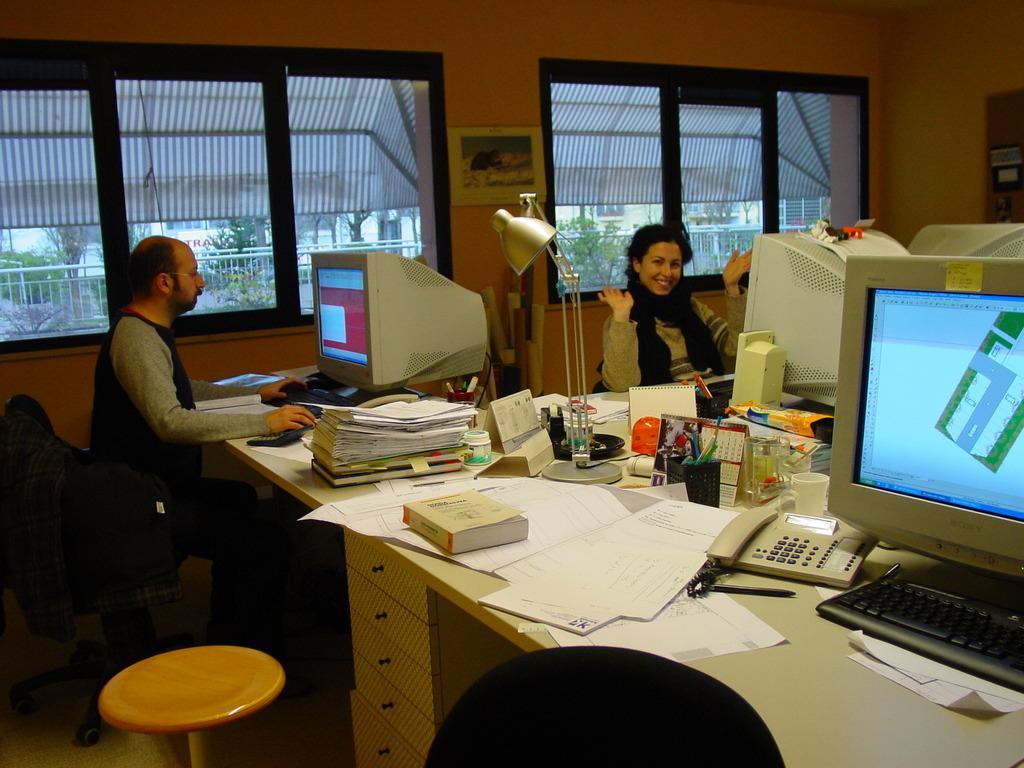Can you describe this image briefly? In the image we can see two persons were sitting on the chair around the table. On table we can see monitor,books,papers,and phone,calendar,glass,lamp,mouse etc. In the background there is a wall and window. In the bottom we can see one stool and one chair. 